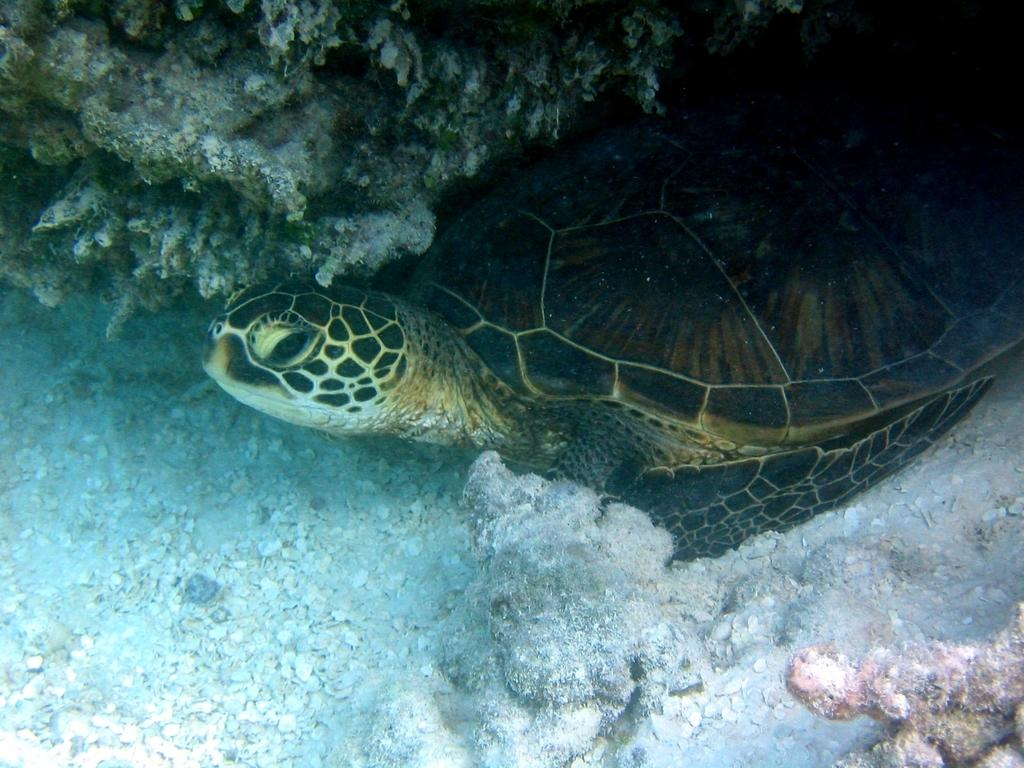What animal is in the image? There is a tortoise in the image. Where is the tortoise located? The tortoise is in the water. What type of poison is the tortoise using to defend itself in the image? There is no poison present in the image; the tortoise is simply in the water. 